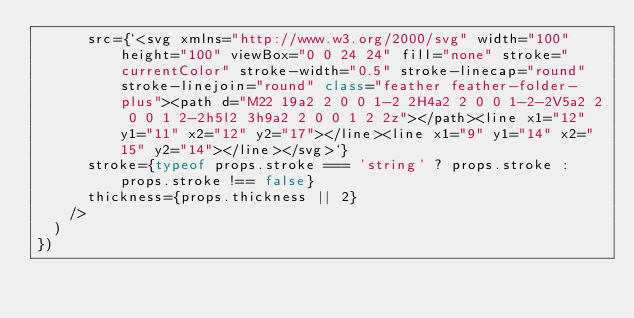Convert code to text. <code><loc_0><loc_0><loc_500><loc_500><_TypeScript_>      src={`<svg xmlns="http://www.w3.org/2000/svg" width="100" height="100" viewBox="0 0 24 24" fill="none" stroke="currentColor" stroke-width="0.5" stroke-linecap="round" stroke-linejoin="round" class="feather feather-folder-plus"><path d="M22 19a2 2 0 0 1-2 2H4a2 2 0 0 1-2-2V5a2 2 0 0 1 2-2h5l2 3h9a2 2 0 0 1 2 2z"></path><line x1="12" y1="11" x2="12" y2="17"></line><line x1="9" y1="14" x2="15" y2="14"></line></svg>`}
      stroke={typeof props.stroke === 'string' ? props.stroke : props.stroke !== false}
      thickness={props.thickness || 2}
    />
  )
})
</code> 